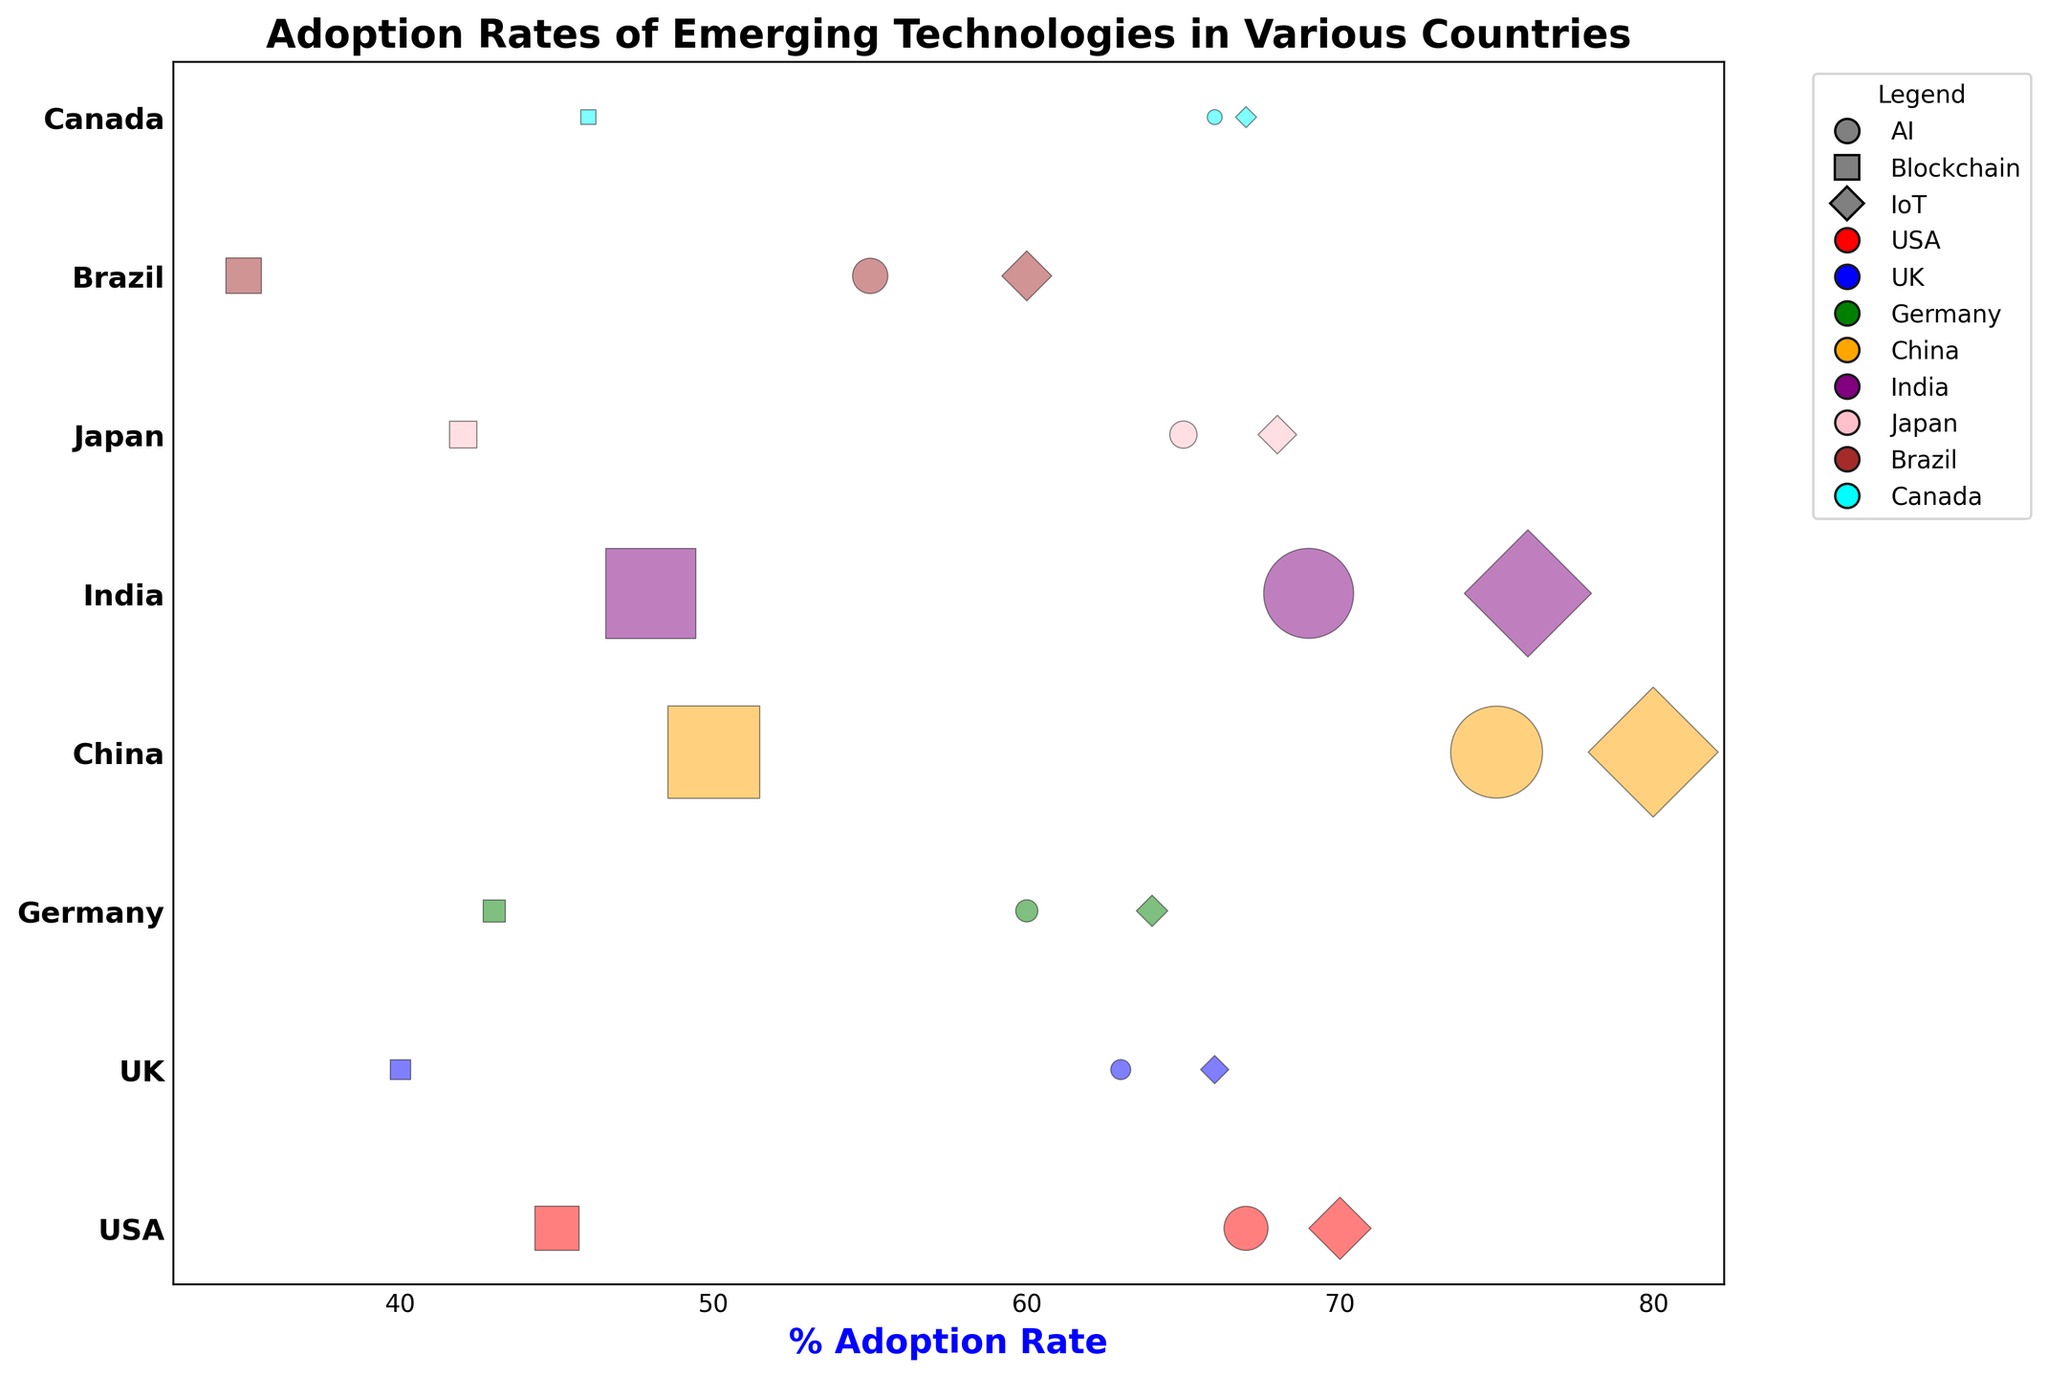Which country has the highest adoption rate of IoT technology? To find the country with the highest adoption rate of IoT technology, look for the IoT markers and compare their positions on the X-axis, which represents the adoption rate percentage. The country with the highest value will be the one
Answer: China Between AI and Blockchain, which technology has a higher adoption rate in Canada? Compare the markers representing Canada for AI and Blockchain on the X-axis to see which has a higher adoption rate percentage
Answer: AI What is the average adoption rate of AI technology across all countries? Sum the adoption rates for AI technology in all countries and divide by the number of countries (67+63+60+75+69+65+55+66)/8
Answer: 65.0 Which country has the largest population bubble for Blockchain technology? Look for the size of the bubbles corresponding to Blockchain in each country and identify the largest one
Answer: China Compare the adoption rates of IoT technology between Germany and Brazil. Which country has a higher rate and by how much? Find the IoT adoption rate for both Germany and Brazil on the X-axis. Subtract Brazil's rate from Germany's rate to determine the difference
Answer: Germany by 4 If we sum the adoption rates of AI and IoT technology in the USA, what is the result? Add the adoption rates of AI (67) and IoT (70) in the USA
Answer: 137 Considering both visual size and color, which country is represented by the smallest population bubble for AI technology and what is its adoption rate? Look for the smallest bubble in the AI category and note its color to identify the country, then read its adoption rate
Answer: Canada, 66 Is the adoption rate of Blockchain technology higher in the UK or Japan? Compare the Blockchain technology markers for the UK and Japan, observing their positions on the X-axis
Answer: UK What is the median adoption rate of IoT technology across all countries? Arrange the IoT adoption rates in ascending order and find the middle value or the average of the two middle values since there is an even number of countries
Answer: 67 Which technology shows a higher adoption rate in all countries: AI or IoT? Examine AI and IoT adoption rates for each country and compare; determine which is consistently higher or has higher rates in more countries
Answer: IoT 